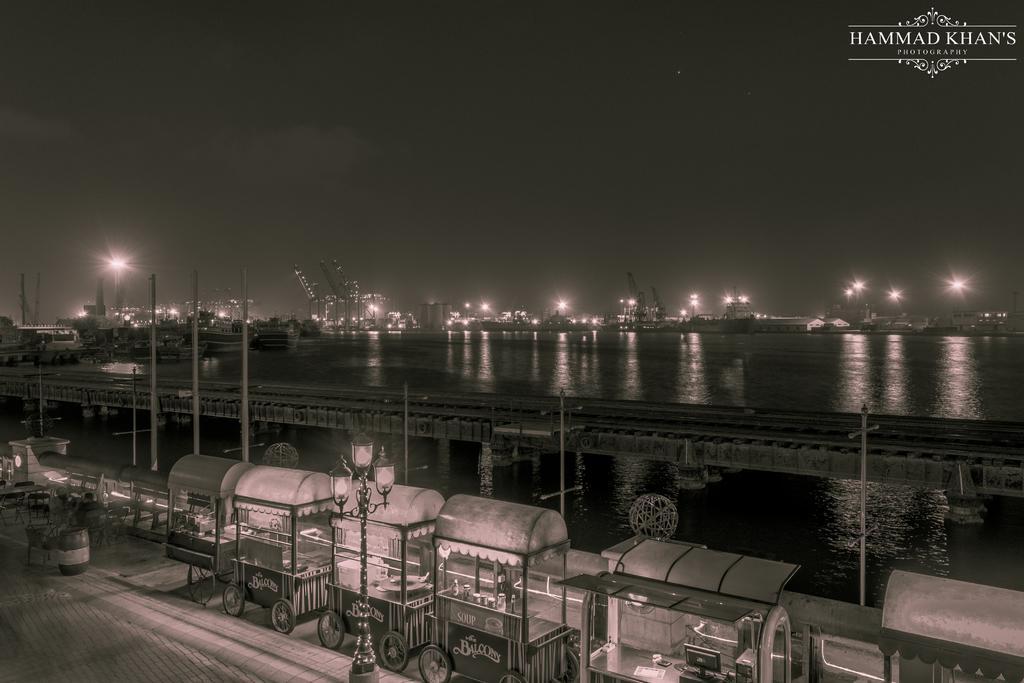Can you describe this image briefly? In this image, we can see a bridge, poles, water. At the bottom, we can see a footpath, some stalls, pole with lights, tables and chairs, dustbin. Background there are so many lights, towers we can see. Top of the image, there is a sky. Right side top corner, we can see a watermark in the image. 